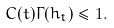<formula> <loc_0><loc_0><loc_500><loc_500>C ( t ) \Gamma ( h _ { t } ) \leq 1 .</formula> 